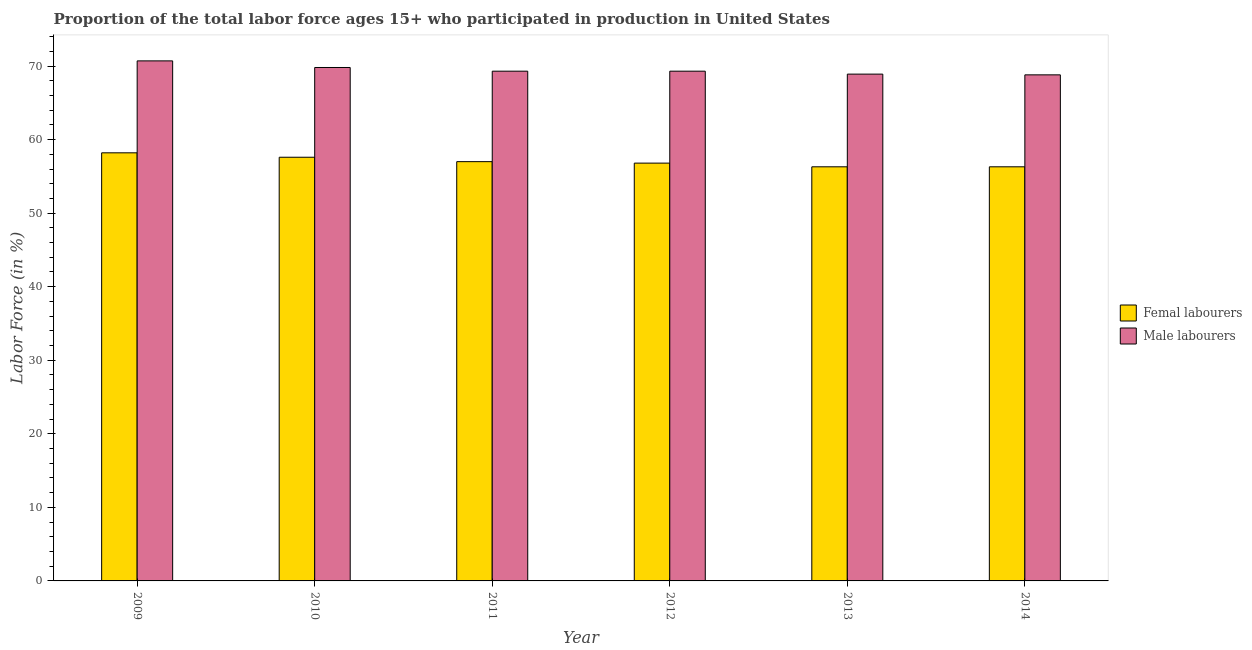How many bars are there on the 1st tick from the left?
Make the answer very short. 2. How many bars are there on the 5th tick from the right?
Make the answer very short. 2. What is the label of the 5th group of bars from the left?
Make the answer very short. 2013. What is the percentage of male labour force in 2010?
Offer a terse response. 69.8. Across all years, what is the maximum percentage of female labor force?
Offer a terse response. 58.2. Across all years, what is the minimum percentage of female labor force?
Your answer should be compact. 56.3. In which year was the percentage of female labor force maximum?
Give a very brief answer. 2009. In which year was the percentage of male labour force minimum?
Ensure brevity in your answer.  2014. What is the total percentage of male labour force in the graph?
Keep it short and to the point. 416.8. What is the difference between the percentage of female labor force in 2009 and that in 2014?
Provide a succinct answer. 1.9. What is the difference between the percentage of male labour force in 2013 and the percentage of female labor force in 2014?
Ensure brevity in your answer.  0.1. What is the average percentage of female labor force per year?
Your answer should be compact. 57.03. In how many years, is the percentage of male labour force greater than 20 %?
Provide a short and direct response. 6. Is the percentage of female labor force in 2009 less than that in 2011?
Offer a very short reply. No. Is the difference between the percentage of male labour force in 2009 and 2013 greater than the difference between the percentage of female labor force in 2009 and 2013?
Offer a terse response. No. What is the difference between the highest and the second highest percentage of female labor force?
Provide a succinct answer. 0.6. What is the difference between the highest and the lowest percentage of female labor force?
Keep it short and to the point. 1.9. In how many years, is the percentage of male labour force greater than the average percentage of male labour force taken over all years?
Your answer should be compact. 2. Is the sum of the percentage of male labour force in 2009 and 2013 greater than the maximum percentage of female labor force across all years?
Make the answer very short. Yes. What does the 1st bar from the left in 2014 represents?
Give a very brief answer. Femal labourers. What does the 2nd bar from the right in 2013 represents?
Give a very brief answer. Femal labourers. How many bars are there?
Give a very brief answer. 12. What is the title of the graph?
Offer a terse response. Proportion of the total labor force ages 15+ who participated in production in United States. What is the label or title of the Y-axis?
Give a very brief answer. Labor Force (in %). What is the Labor Force (in %) in Femal labourers in 2009?
Keep it short and to the point. 58.2. What is the Labor Force (in %) of Male labourers in 2009?
Offer a terse response. 70.7. What is the Labor Force (in %) in Femal labourers in 2010?
Your answer should be very brief. 57.6. What is the Labor Force (in %) of Male labourers in 2010?
Keep it short and to the point. 69.8. What is the Labor Force (in %) in Femal labourers in 2011?
Your response must be concise. 57. What is the Labor Force (in %) of Male labourers in 2011?
Make the answer very short. 69.3. What is the Labor Force (in %) of Femal labourers in 2012?
Make the answer very short. 56.8. What is the Labor Force (in %) of Male labourers in 2012?
Give a very brief answer. 69.3. What is the Labor Force (in %) of Femal labourers in 2013?
Provide a succinct answer. 56.3. What is the Labor Force (in %) in Male labourers in 2013?
Provide a succinct answer. 68.9. What is the Labor Force (in %) in Femal labourers in 2014?
Make the answer very short. 56.3. What is the Labor Force (in %) of Male labourers in 2014?
Keep it short and to the point. 68.8. Across all years, what is the maximum Labor Force (in %) of Femal labourers?
Your response must be concise. 58.2. Across all years, what is the maximum Labor Force (in %) in Male labourers?
Make the answer very short. 70.7. Across all years, what is the minimum Labor Force (in %) in Femal labourers?
Your answer should be compact. 56.3. Across all years, what is the minimum Labor Force (in %) of Male labourers?
Keep it short and to the point. 68.8. What is the total Labor Force (in %) in Femal labourers in the graph?
Your answer should be very brief. 342.2. What is the total Labor Force (in %) in Male labourers in the graph?
Keep it short and to the point. 416.8. What is the difference between the Labor Force (in %) of Femal labourers in 2009 and that in 2010?
Offer a terse response. 0.6. What is the difference between the Labor Force (in %) in Male labourers in 2009 and that in 2010?
Keep it short and to the point. 0.9. What is the difference between the Labor Force (in %) of Male labourers in 2009 and that in 2011?
Provide a short and direct response. 1.4. What is the difference between the Labor Force (in %) in Male labourers in 2009 and that in 2012?
Your answer should be compact. 1.4. What is the difference between the Labor Force (in %) in Femal labourers in 2009 and that in 2013?
Keep it short and to the point. 1.9. What is the difference between the Labor Force (in %) of Male labourers in 2009 and that in 2013?
Provide a succinct answer. 1.8. What is the difference between the Labor Force (in %) in Femal labourers in 2009 and that in 2014?
Ensure brevity in your answer.  1.9. What is the difference between the Labor Force (in %) of Male labourers in 2010 and that in 2011?
Offer a terse response. 0.5. What is the difference between the Labor Force (in %) of Femal labourers in 2010 and that in 2012?
Offer a very short reply. 0.8. What is the difference between the Labor Force (in %) of Male labourers in 2010 and that in 2012?
Your answer should be very brief. 0.5. What is the difference between the Labor Force (in %) in Femal labourers in 2010 and that in 2013?
Offer a terse response. 1.3. What is the difference between the Labor Force (in %) of Femal labourers in 2010 and that in 2014?
Provide a succinct answer. 1.3. What is the difference between the Labor Force (in %) of Male labourers in 2011 and that in 2013?
Offer a very short reply. 0.4. What is the difference between the Labor Force (in %) in Femal labourers in 2011 and that in 2014?
Provide a succinct answer. 0.7. What is the difference between the Labor Force (in %) of Male labourers in 2012 and that in 2013?
Keep it short and to the point. 0.4. What is the difference between the Labor Force (in %) of Femal labourers in 2013 and that in 2014?
Offer a terse response. 0. What is the difference between the Labor Force (in %) of Male labourers in 2013 and that in 2014?
Make the answer very short. 0.1. What is the difference between the Labor Force (in %) of Femal labourers in 2009 and the Labor Force (in %) of Male labourers in 2010?
Make the answer very short. -11.6. What is the difference between the Labor Force (in %) in Femal labourers in 2009 and the Labor Force (in %) in Male labourers in 2012?
Offer a very short reply. -11.1. What is the difference between the Labor Force (in %) in Femal labourers in 2009 and the Labor Force (in %) in Male labourers in 2014?
Give a very brief answer. -10.6. What is the difference between the Labor Force (in %) in Femal labourers in 2010 and the Labor Force (in %) in Male labourers in 2012?
Keep it short and to the point. -11.7. What is the difference between the Labor Force (in %) of Femal labourers in 2011 and the Labor Force (in %) of Male labourers in 2014?
Provide a short and direct response. -11.8. What is the difference between the Labor Force (in %) in Femal labourers in 2012 and the Labor Force (in %) in Male labourers in 2013?
Your answer should be very brief. -12.1. What is the difference between the Labor Force (in %) in Femal labourers in 2012 and the Labor Force (in %) in Male labourers in 2014?
Ensure brevity in your answer.  -12. What is the average Labor Force (in %) of Femal labourers per year?
Your answer should be compact. 57.03. What is the average Labor Force (in %) of Male labourers per year?
Offer a very short reply. 69.47. What is the ratio of the Labor Force (in %) of Femal labourers in 2009 to that in 2010?
Your answer should be compact. 1.01. What is the ratio of the Labor Force (in %) of Male labourers in 2009 to that in 2010?
Keep it short and to the point. 1.01. What is the ratio of the Labor Force (in %) of Femal labourers in 2009 to that in 2011?
Provide a short and direct response. 1.02. What is the ratio of the Labor Force (in %) in Male labourers in 2009 to that in 2011?
Provide a succinct answer. 1.02. What is the ratio of the Labor Force (in %) in Femal labourers in 2009 to that in 2012?
Make the answer very short. 1.02. What is the ratio of the Labor Force (in %) in Male labourers in 2009 to that in 2012?
Offer a terse response. 1.02. What is the ratio of the Labor Force (in %) of Femal labourers in 2009 to that in 2013?
Provide a succinct answer. 1.03. What is the ratio of the Labor Force (in %) in Male labourers in 2009 to that in 2013?
Provide a succinct answer. 1.03. What is the ratio of the Labor Force (in %) of Femal labourers in 2009 to that in 2014?
Give a very brief answer. 1.03. What is the ratio of the Labor Force (in %) of Male labourers in 2009 to that in 2014?
Your answer should be compact. 1.03. What is the ratio of the Labor Force (in %) in Femal labourers in 2010 to that in 2011?
Offer a very short reply. 1.01. What is the ratio of the Labor Force (in %) in Femal labourers in 2010 to that in 2012?
Provide a short and direct response. 1.01. What is the ratio of the Labor Force (in %) of Male labourers in 2010 to that in 2012?
Ensure brevity in your answer.  1.01. What is the ratio of the Labor Force (in %) in Femal labourers in 2010 to that in 2013?
Keep it short and to the point. 1.02. What is the ratio of the Labor Force (in %) of Male labourers in 2010 to that in 2013?
Your answer should be very brief. 1.01. What is the ratio of the Labor Force (in %) in Femal labourers in 2010 to that in 2014?
Your response must be concise. 1.02. What is the ratio of the Labor Force (in %) in Male labourers in 2010 to that in 2014?
Give a very brief answer. 1.01. What is the ratio of the Labor Force (in %) in Femal labourers in 2011 to that in 2012?
Your answer should be very brief. 1. What is the ratio of the Labor Force (in %) of Male labourers in 2011 to that in 2012?
Provide a succinct answer. 1. What is the ratio of the Labor Force (in %) in Femal labourers in 2011 to that in 2013?
Your response must be concise. 1.01. What is the ratio of the Labor Force (in %) of Male labourers in 2011 to that in 2013?
Provide a short and direct response. 1.01. What is the ratio of the Labor Force (in %) of Femal labourers in 2011 to that in 2014?
Give a very brief answer. 1.01. What is the ratio of the Labor Force (in %) in Male labourers in 2011 to that in 2014?
Your response must be concise. 1.01. What is the ratio of the Labor Force (in %) of Femal labourers in 2012 to that in 2013?
Your answer should be very brief. 1.01. What is the ratio of the Labor Force (in %) in Femal labourers in 2012 to that in 2014?
Your answer should be compact. 1.01. What is the ratio of the Labor Force (in %) of Male labourers in 2012 to that in 2014?
Provide a succinct answer. 1.01. What is the difference between the highest and the second highest Labor Force (in %) in Femal labourers?
Your answer should be very brief. 0.6. What is the difference between the highest and the second highest Labor Force (in %) of Male labourers?
Give a very brief answer. 0.9. What is the difference between the highest and the lowest Labor Force (in %) in Male labourers?
Give a very brief answer. 1.9. 